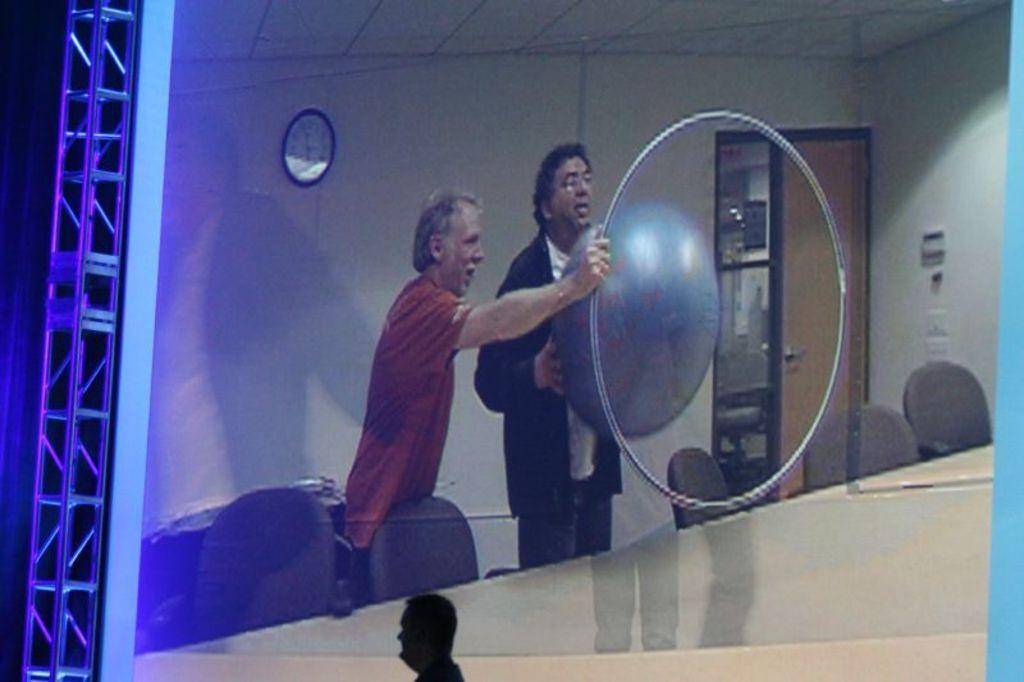Could you give a brief overview of what you see in this image? At the bottom of the image a person is standing. Behind him there is a screen. In the screen few people are standing and holding some toys and there are some chairs and tables. Behind them there is a wall, on the wall there is a clock. 